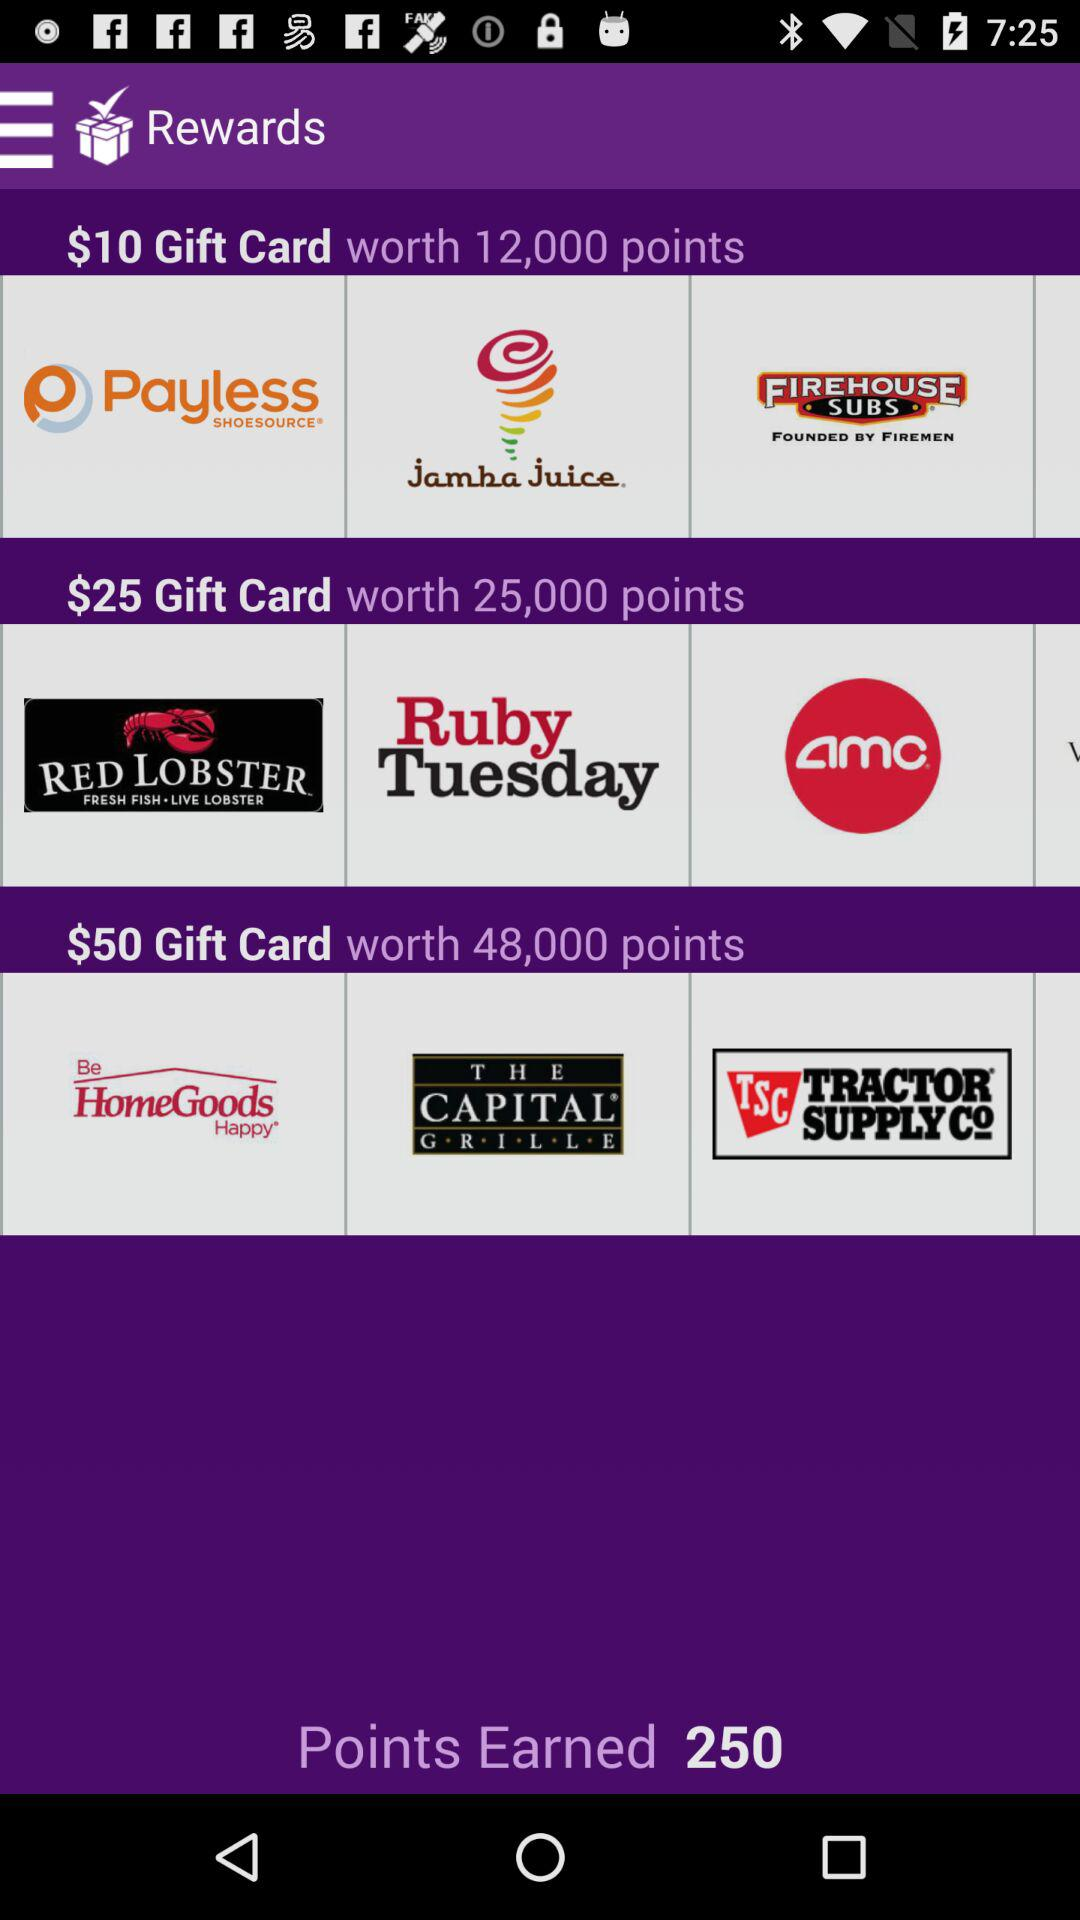How many points were earned? There were 250 points earned. 